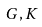Convert formula to latex. <formula><loc_0><loc_0><loc_500><loc_500>G , K</formula> 